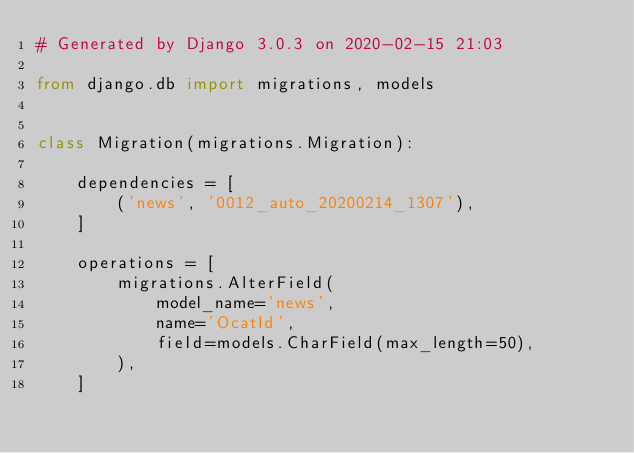<code> <loc_0><loc_0><loc_500><loc_500><_Python_># Generated by Django 3.0.3 on 2020-02-15 21:03

from django.db import migrations, models


class Migration(migrations.Migration):

    dependencies = [
        ('news', '0012_auto_20200214_1307'),
    ]

    operations = [
        migrations.AlterField(
            model_name='news',
            name='OcatId',
            field=models.CharField(max_length=50),
        ),
    ]
</code> 